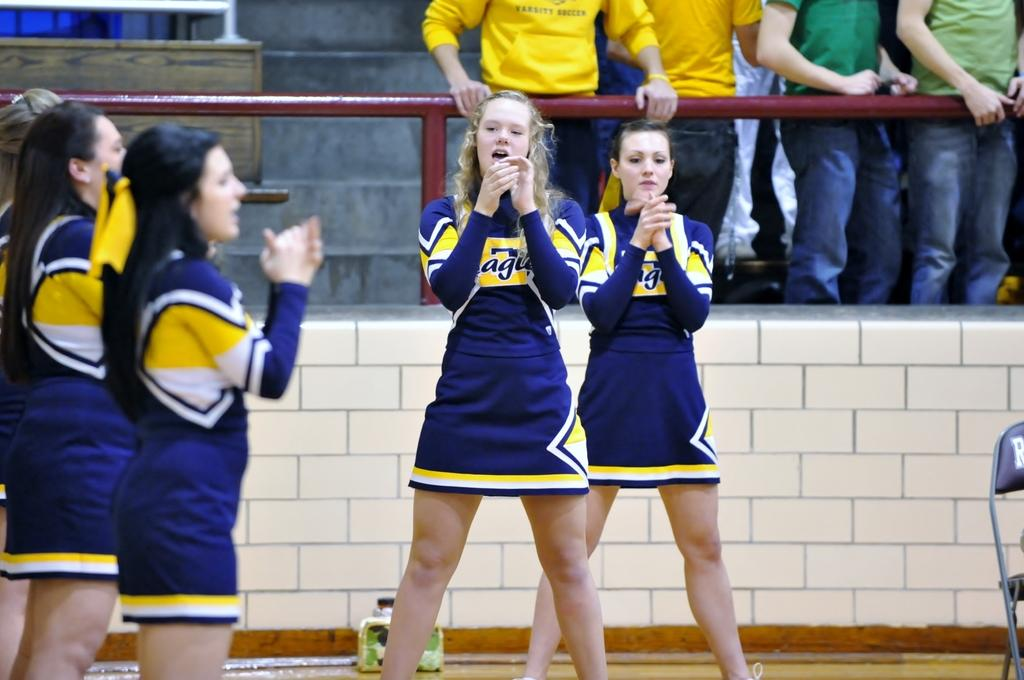<image>
Offer a succinct explanation of the picture presented. A person in the audience has a yellow sweatshirt that has the words varsity soccer. 